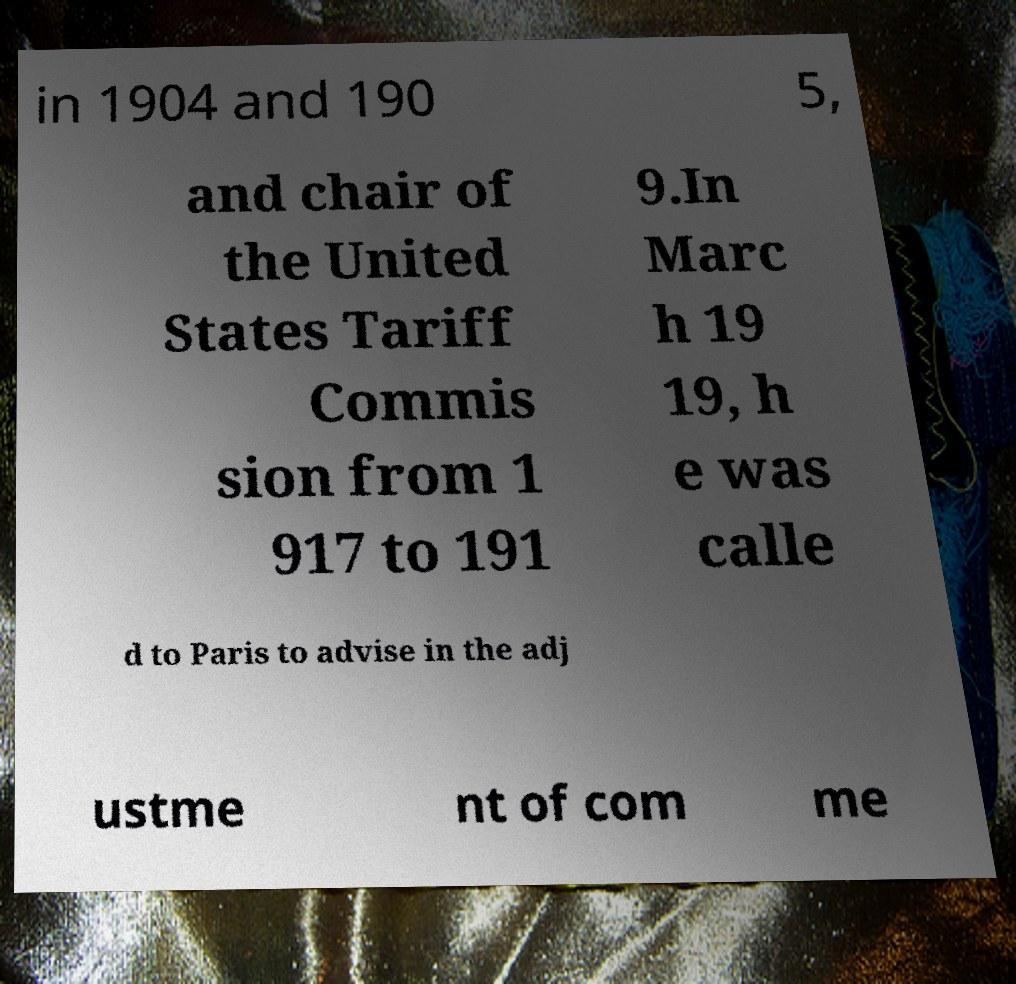Can you accurately transcribe the text from the provided image for me? in 1904 and 190 5, and chair of the United States Tariff Commis sion from 1 917 to 191 9.In Marc h 19 19, h e was calle d to Paris to advise in the adj ustme nt of com me 